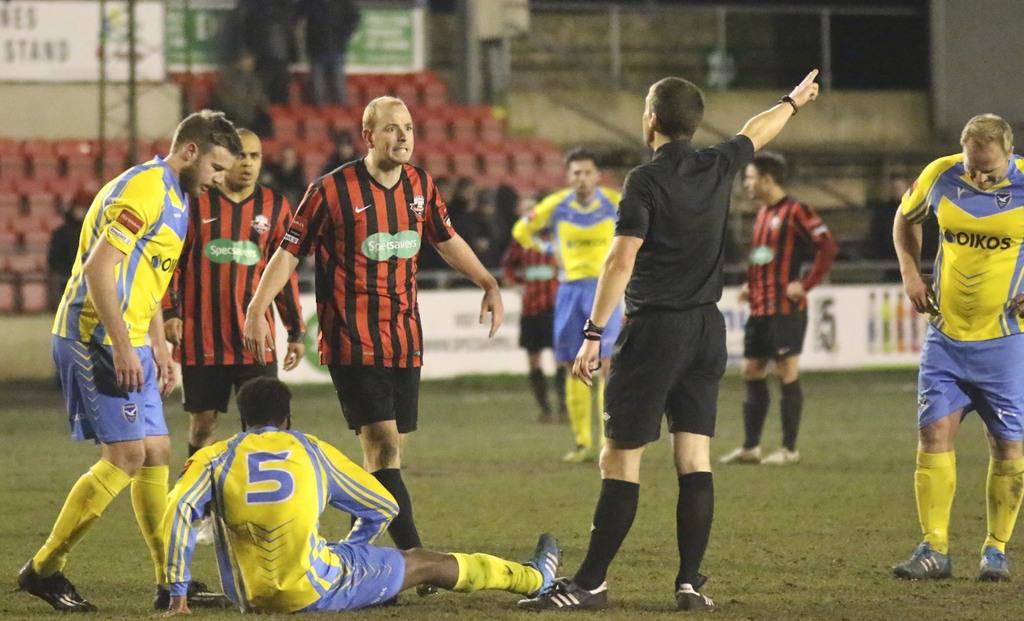What number is the hurt player?
Your answer should be very brief. 5. 